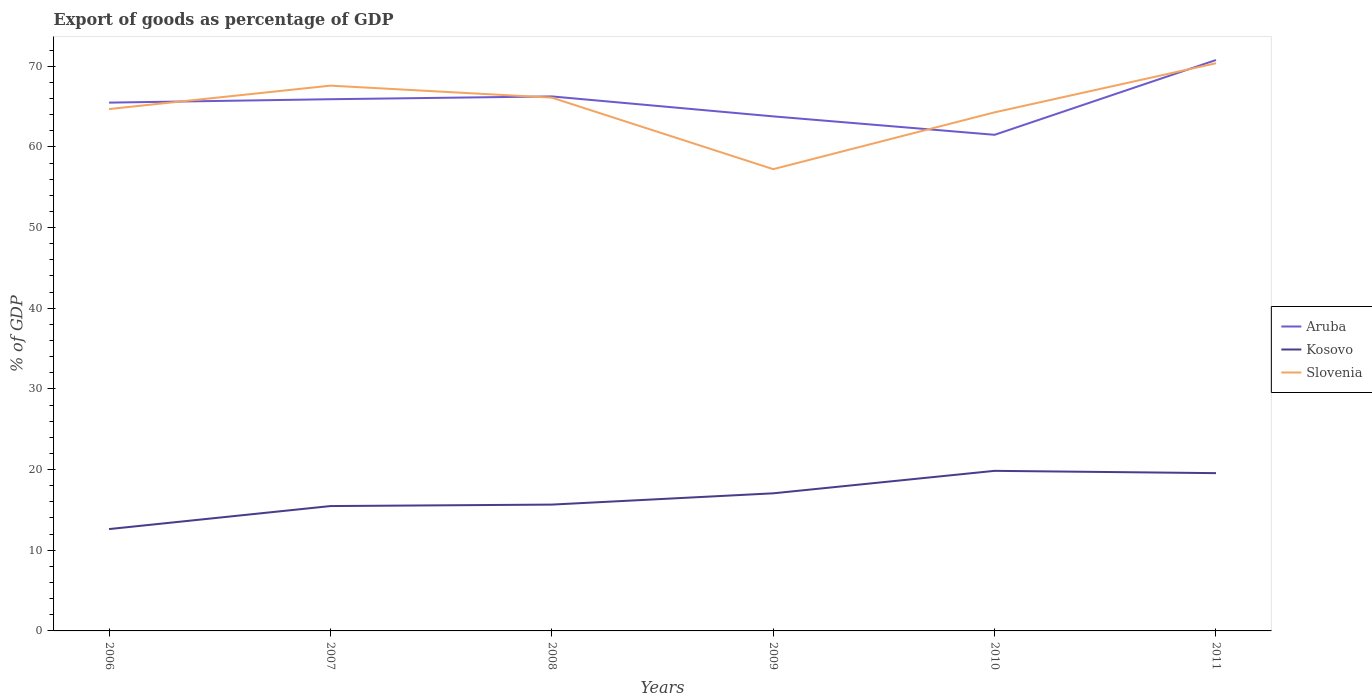How many different coloured lines are there?
Keep it short and to the point. 3. Across all years, what is the maximum export of goods as percentage of GDP in Kosovo?
Provide a succinct answer. 12.62. In which year was the export of goods as percentage of GDP in Kosovo maximum?
Ensure brevity in your answer.  2006. What is the total export of goods as percentage of GDP in Aruba in the graph?
Your response must be concise. -0.35. What is the difference between the highest and the second highest export of goods as percentage of GDP in Aruba?
Provide a short and direct response. 9.27. What is the difference between the highest and the lowest export of goods as percentage of GDP in Kosovo?
Give a very brief answer. 3. Is the export of goods as percentage of GDP in Aruba strictly greater than the export of goods as percentage of GDP in Kosovo over the years?
Your response must be concise. No. How many years are there in the graph?
Ensure brevity in your answer.  6. What is the difference between two consecutive major ticks on the Y-axis?
Your answer should be compact. 10. Are the values on the major ticks of Y-axis written in scientific E-notation?
Your answer should be compact. No. Does the graph contain grids?
Your answer should be compact. No. Where does the legend appear in the graph?
Offer a terse response. Center right. How are the legend labels stacked?
Your answer should be very brief. Vertical. What is the title of the graph?
Offer a terse response. Export of goods as percentage of GDP. Does "Argentina" appear as one of the legend labels in the graph?
Offer a terse response. No. What is the label or title of the X-axis?
Your answer should be compact. Years. What is the label or title of the Y-axis?
Keep it short and to the point. % of GDP. What is the % of GDP of Aruba in 2006?
Your answer should be compact. 65.49. What is the % of GDP in Kosovo in 2006?
Your answer should be very brief. 12.62. What is the % of GDP of Slovenia in 2006?
Give a very brief answer. 64.7. What is the % of GDP in Aruba in 2007?
Provide a succinct answer. 65.91. What is the % of GDP of Kosovo in 2007?
Provide a succinct answer. 15.48. What is the % of GDP in Slovenia in 2007?
Your answer should be very brief. 67.6. What is the % of GDP in Aruba in 2008?
Offer a terse response. 66.26. What is the % of GDP of Kosovo in 2008?
Give a very brief answer. 15.66. What is the % of GDP of Slovenia in 2008?
Offer a very short reply. 66.11. What is the % of GDP in Aruba in 2009?
Provide a short and direct response. 63.79. What is the % of GDP in Kosovo in 2009?
Your answer should be very brief. 17.06. What is the % of GDP in Slovenia in 2009?
Offer a terse response. 57.24. What is the % of GDP in Aruba in 2010?
Your answer should be very brief. 61.5. What is the % of GDP in Kosovo in 2010?
Provide a short and direct response. 19.85. What is the % of GDP of Slovenia in 2010?
Keep it short and to the point. 64.29. What is the % of GDP in Aruba in 2011?
Your answer should be compact. 70.77. What is the % of GDP of Kosovo in 2011?
Ensure brevity in your answer.  19.56. What is the % of GDP of Slovenia in 2011?
Your response must be concise. 70.37. Across all years, what is the maximum % of GDP of Aruba?
Provide a succinct answer. 70.77. Across all years, what is the maximum % of GDP in Kosovo?
Give a very brief answer. 19.85. Across all years, what is the maximum % of GDP of Slovenia?
Keep it short and to the point. 70.37. Across all years, what is the minimum % of GDP of Aruba?
Offer a very short reply. 61.5. Across all years, what is the minimum % of GDP in Kosovo?
Your response must be concise. 12.62. Across all years, what is the minimum % of GDP in Slovenia?
Your answer should be compact. 57.24. What is the total % of GDP in Aruba in the graph?
Make the answer very short. 393.73. What is the total % of GDP of Kosovo in the graph?
Provide a short and direct response. 100.23. What is the total % of GDP in Slovenia in the graph?
Provide a short and direct response. 390.31. What is the difference between the % of GDP in Aruba in 2006 and that in 2007?
Provide a succinct answer. -0.42. What is the difference between the % of GDP of Kosovo in 2006 and that in 2007?
Offer a very short reply. -2.85. What is the difference between the % of GDP in Slovenia in 2006 and that in 2007?
Offer a very short reply. -2.9. What is the difference between the % of GDP of Aruba in 2006 and that in 2008?
Give a very brief answer. -0.77. What is the difference between the % of GDP of Kosovo in 2006 and that in 2008?
Provide a succinct answer. -3.04. What is the difference between the % of GDP in Slovenia in 2006 and that in 2008?
Ensure brevity in your answer.  -1.41. What is the difference between the % of GDP in Aruba in 2006 and that in 2009?
Provide a succinct answer. 1.7. What is the difference between the % of GDP of Kosovo in 2006 and that in 2009?
Offer a terse response. -4.43. What is the difference between the % of GDP in Slovenia in 2006 and that in 2009?
Your answer should be compact. 7.45. What is the difference between the % of GDP of Aruba in 2006 and that in 2010?
Give a very brief answer. 3.99. What is the difference between the % of GDP of Kosovo in 2006 and that in 2010?
Provide a short and direct response. -7.22. What is the difference between the % of GDP of Slovenia in 2006 and that in 2010?
Your response must be concise. 0.41. What is the difference between the % of GDP in Aruba in 2006 and that in 2011?
Provide a short and direct response. -5.28. What is the difference between the % of GDP of Kosovo in 2006 and that in 2011?
Your response must be concise. -6.93. What is the difference between the % of GDP in Slovenia in 2006 and that in 2011?
Your answer should be compact. -5.68. What is the difference between the % of GDP in Aruba in 2007 and that in 2008?
Your answer should be compact. -0.35. What is the difference between the % of GDP in Kosovo in 2007 and that in 2008?
Provide a short and direct response. -0.18. What is the difference between the % of GDP in Slovenia in 2007 and that in 2008?
Your response must be concise. 1.49. What is the difference between the % of GDP in Aruba in 2007 and that in 2009?
Offer a very short reply. 2.13. What is the difference between the % of GDP in Kosovo in 2007 and that in 2009?
Provide a succinct answer. -1.58. What is the difference between the % of GDP in Slovenia in 2007 and that in 2009?
Ensure brevity in your answer.  10.35. What is the difference between the % of GDP of Aruba in 2007 and that in 2010?
Make the answer very short. 4.41. What is the difference between the % of GDP of Kosovo in 2007 and that in 2010?
Provide a succinct answer. -4.37. What is the difference between the % of GDP of Slovenia in 2007 and that in 2010?
Ensure brevity in your answer.  3.31. What is the difference between the % of GDP in Aruba in 2007 and that in 2011?
Make the answer very short. -4.86. What is the difference between the % of GDP in Kosovo in 2007 and that in 2011?
Provide a succinct answer. -4.08. What is the difference between the % of GDP in Slovenia in 2007 and that in 2011?
Give a very brief answer. -2.78. What is the difference between the % of GDP in Aruba in 2008 and that in 2009?
Offer a very short reply. 2.47. What is the difference between the % of GDP in Kosovo in 2008 and that in 2009?
Your answer should be compact. -1.4. What is the difference between the % of GDP in Slovenia in 2008 and that in 2009?
Make the answer very short. 8.87. What is the difference between the % of GDP of Aruba in 2008 and that in 2010?
Give a very brief answer. 4.76. What is the difference between the % of GDP in Kosovo in 2008 and that in 2010?
Your answer should be compact. -4.18. What is the difference between the % of GDP of Slovenia in 2008 and that in 2010?
Offer a terse response. 1.82. What is the difference between the % of GDP in Aruba in 2008 and that in 2011?
Provide a short and direct response. -4.51. What is the difference between the % of GDP in Kosovo in 2008 and that in 2011?
Your response must be concise. -3.9. What is the difference between the % of GDP in Slovenia in 2008 and that in 2011?
Offer a very short reply. -4.27. What is the difference between the % of GDP of Aruba in 2009 and that in 2010?
Offer a terse response. 2.28. What is the difference between the % of GDP of Kosovo in 2009 and that in 2010?
Your answer should be compact. -2.79. What is the difference between the % of GDP of Slovenia in 2009 and that in 2010?
Give a very brief answer. -7.05. What is the difference between the % of GDP in Aruba in 2009 and that in 2011?
Provide a succinct answer. -6.99. What is the difference between the % of GDP of Kosovo in 2009 and that in 2011?
Offer a terse response. -2.5. What is the difference between the % of GDP of Slovenia in 2009 and that in 2011?
Give a very brief answer. -13.13. What is the difference between the % of GDP of Aruba in 2010 and that in 2011?
Provide a short and direct response. -9.27. What is the difference between the % of GDP in Kosovo in 2010 and that in 2011?
Offer a terse response. 0.29. What is the difference between the % of GDP in Slovenia in 2010 and that in 2011?
Offer a terse response. -6.09. What is the difference between the % of GDP of Aruba in 2006 and the % of GDP of Kosovo in 2007?
Keep it short and to the point. 50.01. What is the difference between the % of GDP in Aruba in 2006 and the % of GDP in Slovenia in 2007?
Offer a very short reply. -2.11. What is the difference between the % of GDP of Kosovo in 2006 and the % of GDP of Slovenia in 2007?
Keep it short and to the point. -54.97. What is the difference between the % of GDP in Aruba in 2006 and the % of GDP in Kosovo in 2008?
Offer a terse response. 49.83. What is the difference between the % of GDP in Aruba in 2006 and the % of GDP in Slovenia in 2008?
Provide a short and direct response. -0.62. What is the difference between the % of GDP in Kosovo in 2006 and the % of GDP in Slovenia in 2008?
Your answer should be very brief. -53.48. What is the difference between the % of GDP of Aruba in 2006 and the % of GDP of Kosovo in 2009?
Your answer should be compact. 48.43. What is the difference between the % of GDP of Aruba in 2006 and the % of GDP of Slovenia in 2009?
Offer a very short reply. 8.25. What is the difference between the % of GDP in Kosovo in 2006 and the % of GDP in Slovenia in 2009?
Your answer should be compact. -44.62. What is the difference between the % of GDP in Aruba in 2006 and the % of GDP in Kosovo in 2010?
Ensure brevity in your answer.  45.65. What is the difference between the % of GDP of Aruba in 2006 and the % of GDP of Slovenia in 2010?
Provide a short and direct response. 1.2. What is the difference between the % of GDP of Kosovo in 2006 and the % of GDP of Slovenia in 2010?
Your answer should be compact. -51.66. What is the difference between the % of GDP in Aruba in 2006 and the % of GDP in Kosovo in 2011?
Your response must be concise. 45.93. What is the difference between the % of GDP of Aruba in 2006 and the % of GDP of Slovenia in 2011?
Provide a short and direct response. -4.88. What is the difference between the % of GDP in Kosovo in 2006 and the % of GDP in Slovenia in 2011?
Offer a very short reply. -57.75. What is the difference between the % of GDP of Aruba in 2007 and the % of GDP of Kosovo in 2008?
Your answer should be very brief. 50.25. What is the difference between the % of GDP of Aruba in 2007 and the % of GDP of Slovenia in 2008?
Offer a terse response. -0.2. What is the difference between the % of GDP of Kosovo in 2007 and the % of GDP of Slovenia in 2008?
Offer a terse response. -50.63. What is the difference between the % of GDP of Aruba in 2007 and the % of GDP of Kosovo in 2009?
Make the answer very short. 48.85. What is the difference between the % of GDP of Aruba in 2007 and the % of GDP of Slovenia in 2009?
Your answer should be compact. 8.67. What is the difference between the % of GDP in Kosovo in 2007 and the % of GDP in Slovenia in 2009?
Your response must be concise. -41.76. What is the difference between the % of GDP in Aruba in 2007 and the % of GDP in Kosovo in 2010?
Make the answer very short. 46.07. What is the difference between the % of GDP in Aruba in 2007 and the % of GDP in Slovenia in 2010?
Ensure brevity in your answer.  1.62. What is the difference between the % of GDP of Kosovo in 2007 and the % of GDP of Slovenia in 2010?
Offer a terse response. -48.81. What is the difference between the % of GDP in Aruba in 2007 and the % of GDP in Kosovo in 2011?
Keep it short and to the point. 46.35. What is the difference between the % of GDP in Aruba in 2007 and the % of GDP in Slovenia in 2011?
Ensure brevity in your answer.  -4.46. What is the difference between the % of GDP of Kosovo in 2007 and the % of GDP of Slovenia in 2011?
Offer a terse response. -54.9. What is the difference between the % of GDP in Aruba in 2008 and the % of GDP in Kosovo in 2009?
Offer a terse response. 49.2. What is the difference between the % of GDP in Aruba in 2008 and the % of GDP in Slovenia in 2009?
Ensure brevity in your answer.  9.02. What is the difference between the % of GDP in Kosovo in 2008 and the % of GDP in Slovenia in 2009?
Ensure brevity in your answer.  -41.58. What is the difference between the % of GDP in Aruba in 2008 and the % of GDP in Kosovo in 2010?
Offer a very short reply. 46.42. What is the difference between the % of GDP in Aruba in 2008 and the % of GDP in Slovenia in 2010?
Offer a very short reply. 1.97. What is the difference between the % of GDP of Kosovo in 2008 and the % of GDP of Slovenia in 2010?
Provide a succinct answer. -48.63. What is the difference between the % of GDP of Aruba in 2008 and the % of GDP of Kosovo in 2011?
Make the answer very short. 46.7. What is the difference between the % of GDP in Aruba in 2008 and the % of GDP in Slovenia in 2011?
Your answer should be compact. -4.11. What is the difference between the % of GDP in Kosovo in 2008 and the % of GDP in Slovenia in 2011?
Give a very brief answer. -54.71. What is the difference between the % of GDP of Aruba in 2009 and the % of GDP of Kosovo in 2010?
Your answer should be compact. 43.94. What is the difference between the % of GDP in Aruba in 2009 and the % of GDP in Slovenia in 2010?
Provide a succinct answer. -0.5. What is the difference between the % of GDP in Kosovo in 2009 and the % of GDP in Slovenia in 2010?
Provide a short and direct response. -47.23. What is the difference between the % of GDP of Aruba in 2009 and the % of GDP of Kosovo in 2011?
Keep it short and to the point. 44.23. What is the difference between the % of GDP in Aruba in 2009 and the % of GDP in Slovenia in 2011?
Ensure brevity in your answer.  -6.59. What is the difference between the % of GDP in Kosovo in 2009 and the % of GDP in Slovenia in 2011?
Make the answer very short. -53.32. What is the difference between the % of GDP in Aruba in 2010 and the % of GDP in Kosovo in 2011?
Offer a terse response. 41.94. What is the difference between the % of GDP in Aruba in 2010 and the % of GDP in Slovenia in 2011?
Offer a very short reply. -8.87. What is the difference between the % of GDP in Kosovo in 2010 and the % of GDP in Slovenia in 2011?
Provide a short and direct response. -50.53. What is the average % of GDP in Aruba per year?
Offer a terse response. 65.62. What is the average % of GDP of Kosovo per year?
Make the answer very short. 16.7. What is the average % of GDP in Slovenia per year?
Provide a succinct answer. 65.05. In the year 2006, what is the difference between the % of GDP in Aruba and % of GDP in Kosovo?
Provide a succinct answer. 52.87. In the year 2006, what is the difference between the % of GDP in Aruba and % of GDP in Slovenia?
Ensure brevity in your answer.  0.8. In the year 2006, what is the difference between the % of GDP of Kosovo and % of GDP of Slovenia?
Ensure brevity in your answer.  -52.07. In the year 2007, what is the difference between the % of GDP of Aruba and % of GDP of Kosovo?
Your response must be concise. 50.43. In the year 2007, what is the difference between the % of GDP in Aruba and % of GDP in Slovenia?
Ensure brevity in your answer.  -1.68. In the year 2007, what is the difference between the % of GDP of Kosovo and % of GDP of Slovenia?
Ensure brevity in your answer.  -52.12. In the year 2008, what is the difference between the % of GDP in Aruba and % of GDP in Kosovo?
Your answer should be compact. 50.6. In the year 2008, what is the difference between the % of GDP in Aruba and % of GDP in Slovenia?
Provide a short and direct response. 0.15. In the year 2008, what is the difference between the % of GDP in Kosovo and % of GDP in Slovenia?
Provide a succinct answer. -50.45. In the year 2009, what is the difference between the % of GDP in Aruba and % of GDP in Kosovo?
Keep it short and to the point. 46.73. In the year 2009, what is the difference between the % of GDP of Aruba and % of GDP of Slovenia?
Provide a short and direct response. 6.54. In the year 2009, what is the difference between the % of GDP in Kosovo and % of GDP in Slovenia?
Keep it short and to the point. -40.18. In the year 2010, what is the difference between the % of GDP of Aruba and % of GDP of Kosovo?
Give a very brief answer. 41.66. In the year 2010, what is the difference between the % of GDP of Aruba and % of GDP of Slovenia?
Keep it short and to the point. -2.79. In the year 2010, what is the difference between the % of GDP in Kosovo and % of GDP in Slovenia?
Keep it short and to the point. -44.44. In the year 2011, what is the difference between the % of GDP of Aruba and % of GDP of Kosovo?
Ensure brevity in your answer.  51.21. In the year 2011, what is the difference between the % of GDP in Aruba and % of GDP in Slovenia?
Provide a short and direct response. 0.4. In the year 2011, what is the difference between the % of GDP in Kosovo and % of GDP in Slovenia?
Give a very brief answer. -50.81. What is the ratio of the % of GDP in Kosovo in 2006 to that in 2007?
Ensure brevity in your answer.  0.82. What is the ratio of the % of GDP of Slovenia in 2006 to that in 2007?
Make the answer very short. 0.96. What is the ratio of the % of GDP of Aruba in 2006 to that in 2008?
Make the answer very short. 0.99. What is the ratio of the % of GDP in Kosovo in 2006 to that in 2008?
Keep it short and to the point. 0.81. What is the ratio of the % of GDP in Slovenia in 2006 to that in 2008?
Make the answer very short. 0.98. What is the ratio of the % of GDP in Aruba in 2006 to that in 2009?
Ensure brevity in your answer.  1.03. What is the ratio of the % of GDP in Kosovo in 2006 to that in 2009?
Your answer should be very brief. 0.74. What is the ratio of the % of GDP in Slovenia in 2006 to that in 2009?
Your response must be concise. 1.13. What is the ratio of the % of GDP in Aruba in 2006 to that in 2010?
Make the answer very short. 1.06. What is the ratio of the % of GDP of Kosovo in 2006 to that in 2010?
Your answer should be compact. 0.64. What is the ratio of the % of GDP in Slovenia in 2006 to that in 2010?
Offer a terse response. 1.01. What is the ratio of the % of GDP in Aruba in 2006 to that in 2011?
Keep it short and to the point. 0.93. What is the ratio of the % of GDP in Kosovo in 2006 to that in 2011?
Provide a succinct answer. 0.65. What is the ratio of the % of GDP of Slovenia in 2006 to that in 2011?
Give a very brief answer. 0.92. What is the ratio of the % of GDP of Aruba in 2007 to that in 2008?
Offer a very short reply. 0.99. What is the ratio of the % of GDP in Kosovo in 2007 to that in 2008?
Your answer should be very brief. 0.99. What is the ratio of the % of GDP in Slovenia in 2007 to that in 2008?
Provide a succinct answer. 1.02. What is the ratio of the % of GDP of Aruba in 2007 to that in 2009?
Give a very brief answer. 1.03. What is the ratio of the % of GDP in Kosovo in 2007 to that in 2009?
Your answer should be very brief. 0.91. What is the ratio of the % of GDP of Slovenia in 2007 to that in 2009?
Your response must be concise. 1.18. What is the ratio of the % of GDP in Aruba in 2007 to that in 2010?
Give a very brief answer. 1.07. What is the ratio of the % of GDP of Kosovo in 2007 to that in 2010?
Ensure brevity in your answer.  0.78. What is the ratio of the % of GDP in Slovenia in 2007 to that in 2010?
Your response must be concise. 1.05. What is the ratio of the % of GDP in Aruba in 2007 to that in 2011?
Provide a short and direct response. 0.93. What is the ratio of the % of GDP in Kosovo in 2007 to that in 2011?
Provide a succinct answer. 0.79. What is the ratio of the % of GDP in Slovenia in 2007 to that in 2011?
Ensure brevity in your answer.  0.96. What is the ratio of the % of GDP of Aruba in 2008 to that in 2009?
Offer a terse response. 1.04. What is the ratio of the % of GDP of Kosovo in 2008 to that in 2009?
Make the answer very short. 0.92. What is the ratio of the % of GDP of Slovenia in 2008 to that in 2009?
Give a very brief answer. 1.15. What is the ratio of the % of GDP of Aruba in 2008 to that in 2010?
Offer a terse response. 1.08. What is the ratio of the % of GDP in Kosovo in 2008 to that in 2010?
Provide a succinct answer. 0.79. What is the ratio of the % of GDP of Slovenia in 2008 to that in 2010?
Make the answer very short. 1.03. What is the ratio of the % of GDP of Aruba in 2008 to that in 2011?
Provide a succinct answer. 0.94. What is the ratio of the % of GDP in Kosovo in 2008 to that in 2011?
Offer a terse response. 0.8. What is the ratio of the % of GDP of Slovenia in 2008 to that in 2011?
Give a very brief answer. 0.94. What is the ratio of the % of GDP of Aruba in 2009 to that in 2010?
Give a very brief answer. 1.04. What is the ratio of the % of GDP of Kosovo in 2009 to that in 2010?
Make the answer very short. 0.86. What is the ratio of the % of GDP of Slovenia in 2009 to that in 2010?
Keep it short and to the point. 0.89. What is the ratio of the % of GDP in Aruba in 2009 to that in 2011?
Your answer should be compact. 0.9. What is the ratio of the % of GDP in Kosovo in 2009 to that in 2011?
Your response must be concise. 0.87. What is the ratio of the % of GDP of Slovenia in 2009 to that in 2011?
Offer a terse response. 0.81. What is the ratio of the % of GDP of Aruba in 2010 to that in 2011?
Give a very brief answer. 0.87. What is the ratio of the % of GDP of Kosovo in 2010 to that in 2011?
Make the answer very short. 1.01. What is the ratio of the % of GDP in Slovenia in 2010 to that in 2011?
Your response must be concise. 0.91. What is the difference between the highest and the second highest % of GDP in Aruba?
Provide a short and direct response. 4.51. What is the difference between the highest and the second highest % of GDP of Kosovo?
Your response must be concise. 0.29. What is the difference between the highest and the second highest % of GDP in Slovenia?
Keep it short and to the point. 2.78. What is the difference between the highest and the lowest % of GDP in Aruba?
Make the answer very short. 9.27. What is the difference between the highest and the lowest % of GDP of Kosovo?
Make the answer very short. 7.22. What is the difference between the highest and the lowest % of GDP of Slovenia?
Keep it short and to the point. 13.13. 